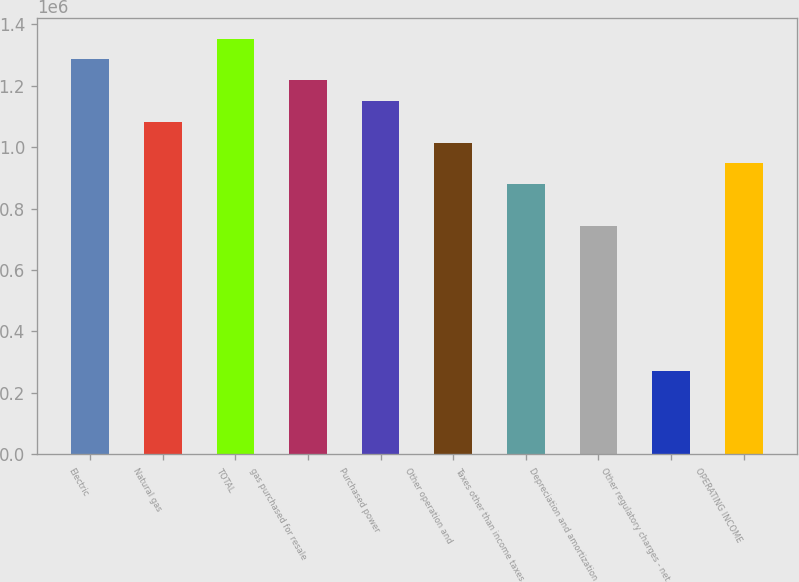Convert chart to OTSL. <chart><loc_0><loc_0><loc_500><loc_500><bar_chart><fcel>Electric<fcel>Natural gas<fcel>TOTAL<fcel>gas purchased for resale<fcel>Purchased power<fcel>Other operation and<fcel>Taxes other than income taxes<fcel>Depreciation and amortization<fcel>Other regulatory charges - net<fcel>OPERATING INCOME<nl><fcel>1.28521e+06<fcel>1.08245e+06<fcel>1.3528e+06<fcel>1.21762e+06<fcel>1.15004e+06<fcel>1.01486e+06<fcel>879688<fcel>744514<fcel>271405<fcel>947275<nl></chart> 